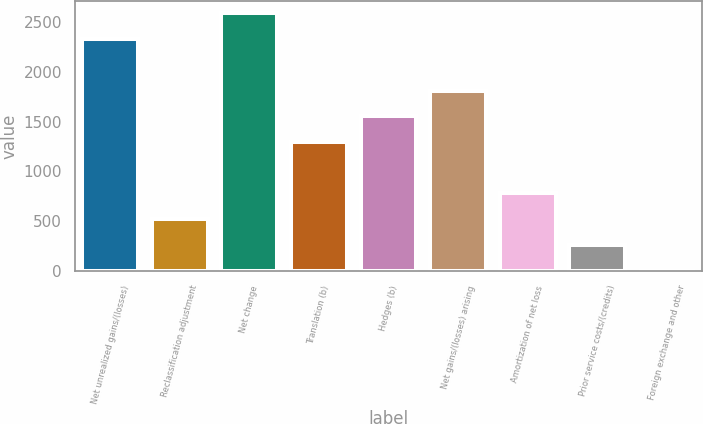Convert chart. <chart><loc_0><loc_0><loc_500><loc_500><bar_chart><fcel>Net unrealized gains/(losses)<fcel>Reclassification adjustment<fcel>Net change<fcel>Translation (b)<fcel>Hedges (b)<fcel>Net gains/(losses) arising<fcel>Amortization of net loss<fcel>Prior service costs/(credits)<fcel>Foreign exchange and other<nl><fcel>2326.1<fcel>520.8<fcel>2584<fcel>1294.5<fcel>1552.4<fcel>1810.3<fcel>778.7<fcel>262.9<fcel>5<nl></chart> 